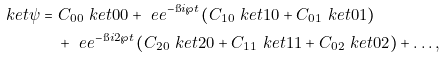<formula> <loc_0><loc_0><loc_500><loc_500>\ k e t { \psi } & = C _ { 0 0 } \ k e t { 0 0 } + \ e e ^ { - \i i \wp t } \left ( C _ { 1 0 } \ k e t { 1 0 } + C _ { 0 1 } \ k e t { 0 1 } \right ) \\ & \quad + \ e e ^ { - \i i 2 \wp t } \left ( C _ { 2 0 } \ k e t { 2 0 } + C _ { 1 1 } \ k e t { 1 1 } + C _ { 0 2 } \ k e t { 0 2 } \right ) + \dots ,</formula> 